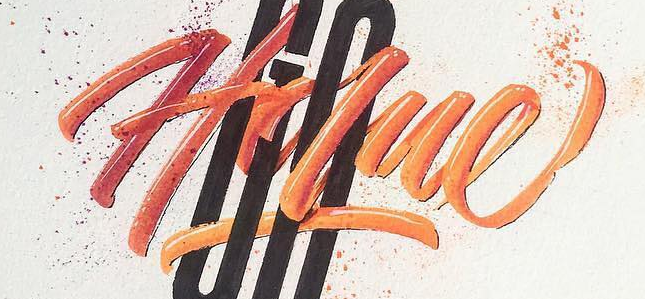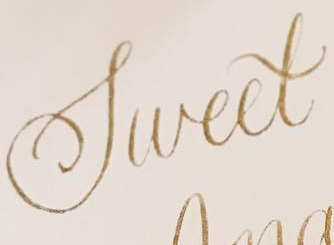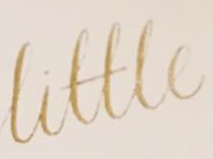Identify the words shown in these images in order, separated by a semicolon. Holue; Sweet; Little 